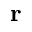Convert formula to latex. <formula><loc_0><loc_0><loc_500><loc_500>{ r }</formula> 